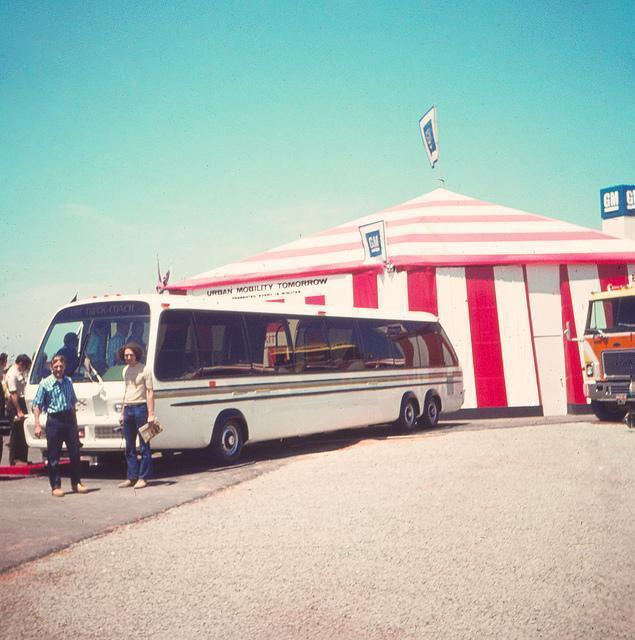How many stones are next to the bus?
Give a very brief answer. 0. How many levels does the bus have?
Give a very brief answer. 1. How many people are there?
Give a very brief answer. 2. How many chairs are there?
Give a very brief answer. 0. 